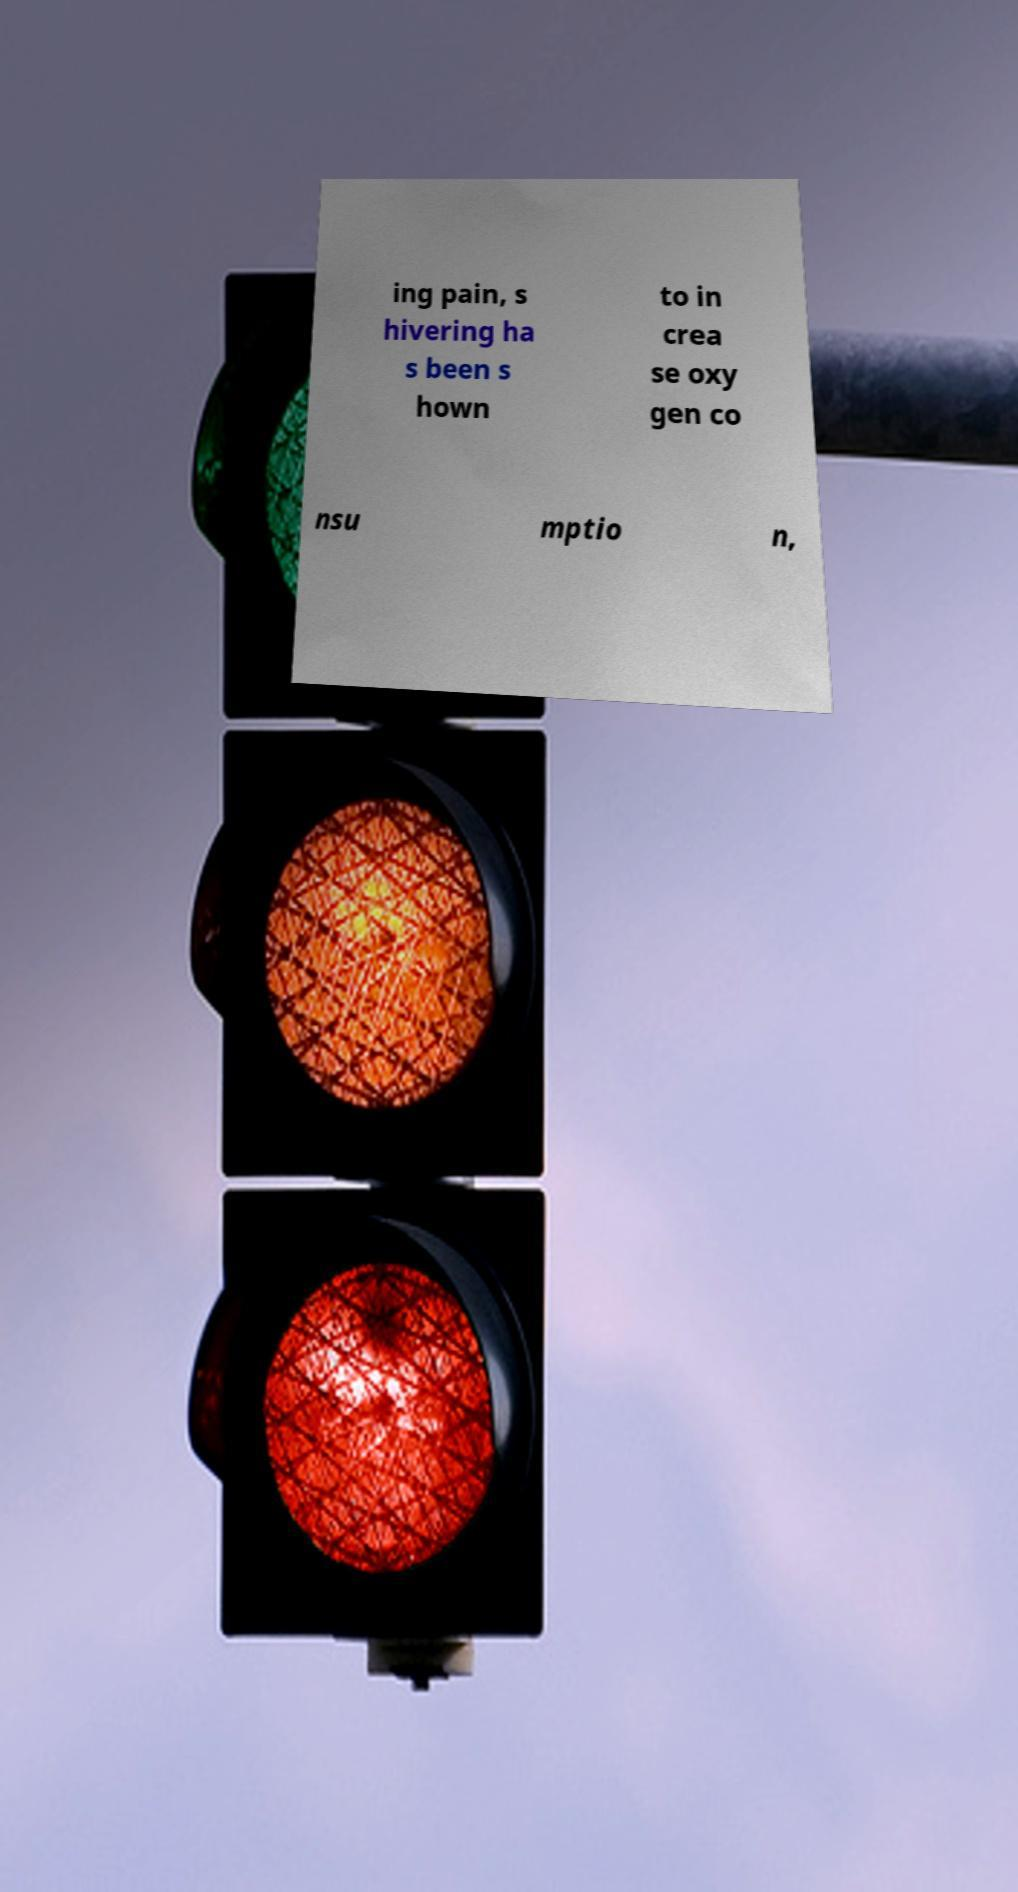What messages or text are displayed in this image? I need them in a readable, typed format. ing pain, s hivering ha s been s hown to in crea se oxy gen co nsu mptio n, 